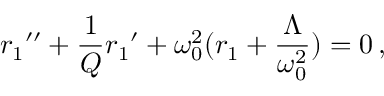<formula> <loc_0><loc_0><loc_500><loc_500>{ r _ { 1 } } ^ { \prime \prime } + \frac { 1 } { Q } { r _ { 1 } } ^ { \prime } + \omega _ { 0 } ^ { 2 } ( r _ { 1 } + \frac { \Lambda } { \omega _ { 0 } ^ { 2 } } ) = 0 \, ,</formula> 